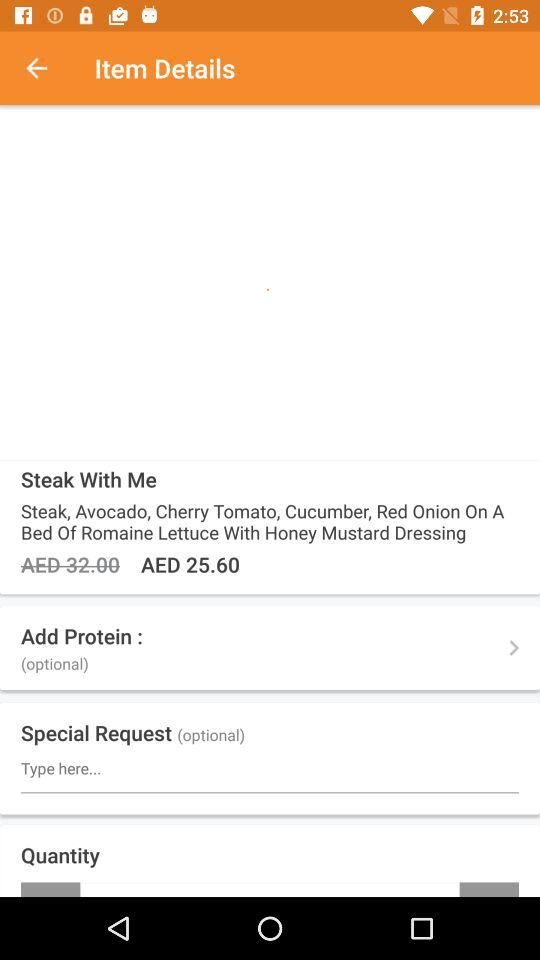What is the price of "Steak With Me"? The price is 25.60 AED. 